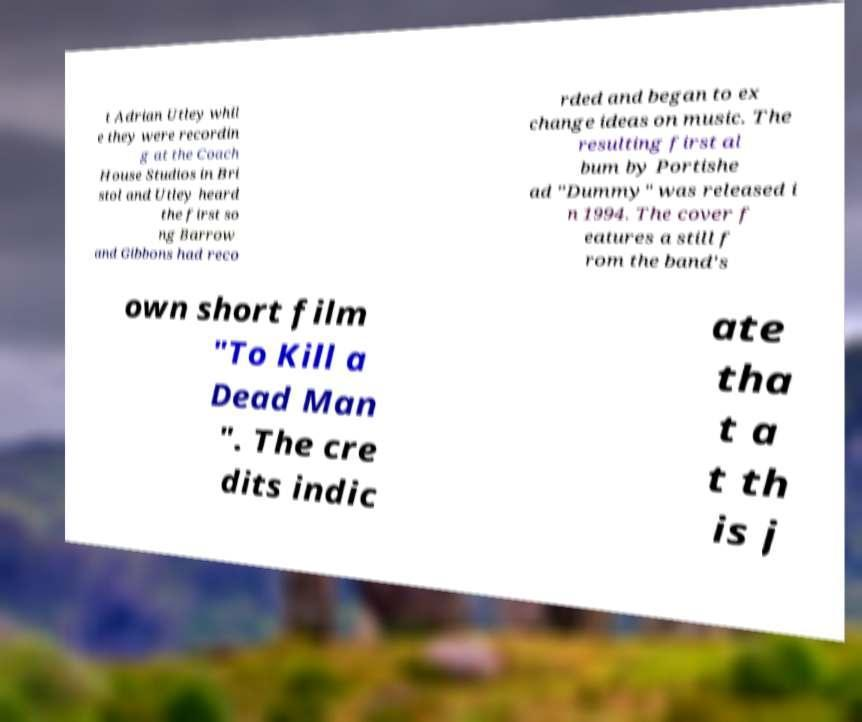I need the written content from this picture converted into text. Can you do that? t Adrian Utley whil e they were recordin g at the Coach House Studios in Bri stol and Utley heard the first so ng Barrow and Gibbons had reco rded and began to ex change ideas on music. The resulting first al bum by Portishe ad "Dummy" was released i n 1994. The cover f eatures a still f rom the band's own short film "To Kill a Dead Man ". The cre dits indic ate tha t a t th is j 